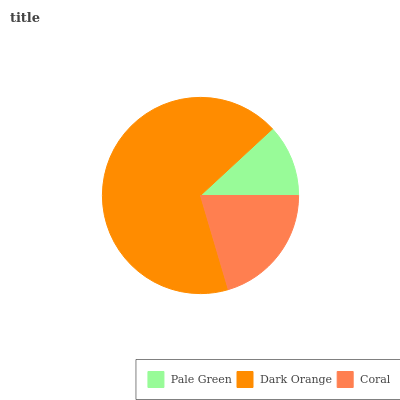Is Pale Green the minimum?
Answer yes or no. Yes. Is Dark Orange the maximum?
Answer yes or no. Yes. Is Coral the minimum?
Answer yes or no. No. Is Coral the maximum?
Answer yes or no. No. Is Dark Orange greater than Coral?
Answer yes or no. Yes. Is Coral less than Dark Orange?
Answer yes or no. Yes. Is Coral greater than Dark Orange?
Answer yes or no. No. Is Dark Orange less than Coral?
Answer yes or no. No. Is Coral the high median?
Answer yes or no. Yes. Is Coral the low median?
Answer yes or no. Yes. Is Dark Orange the high median?
Answer yes or no. No. Is Dark Orange the low median?
Answer yes or no. No. 